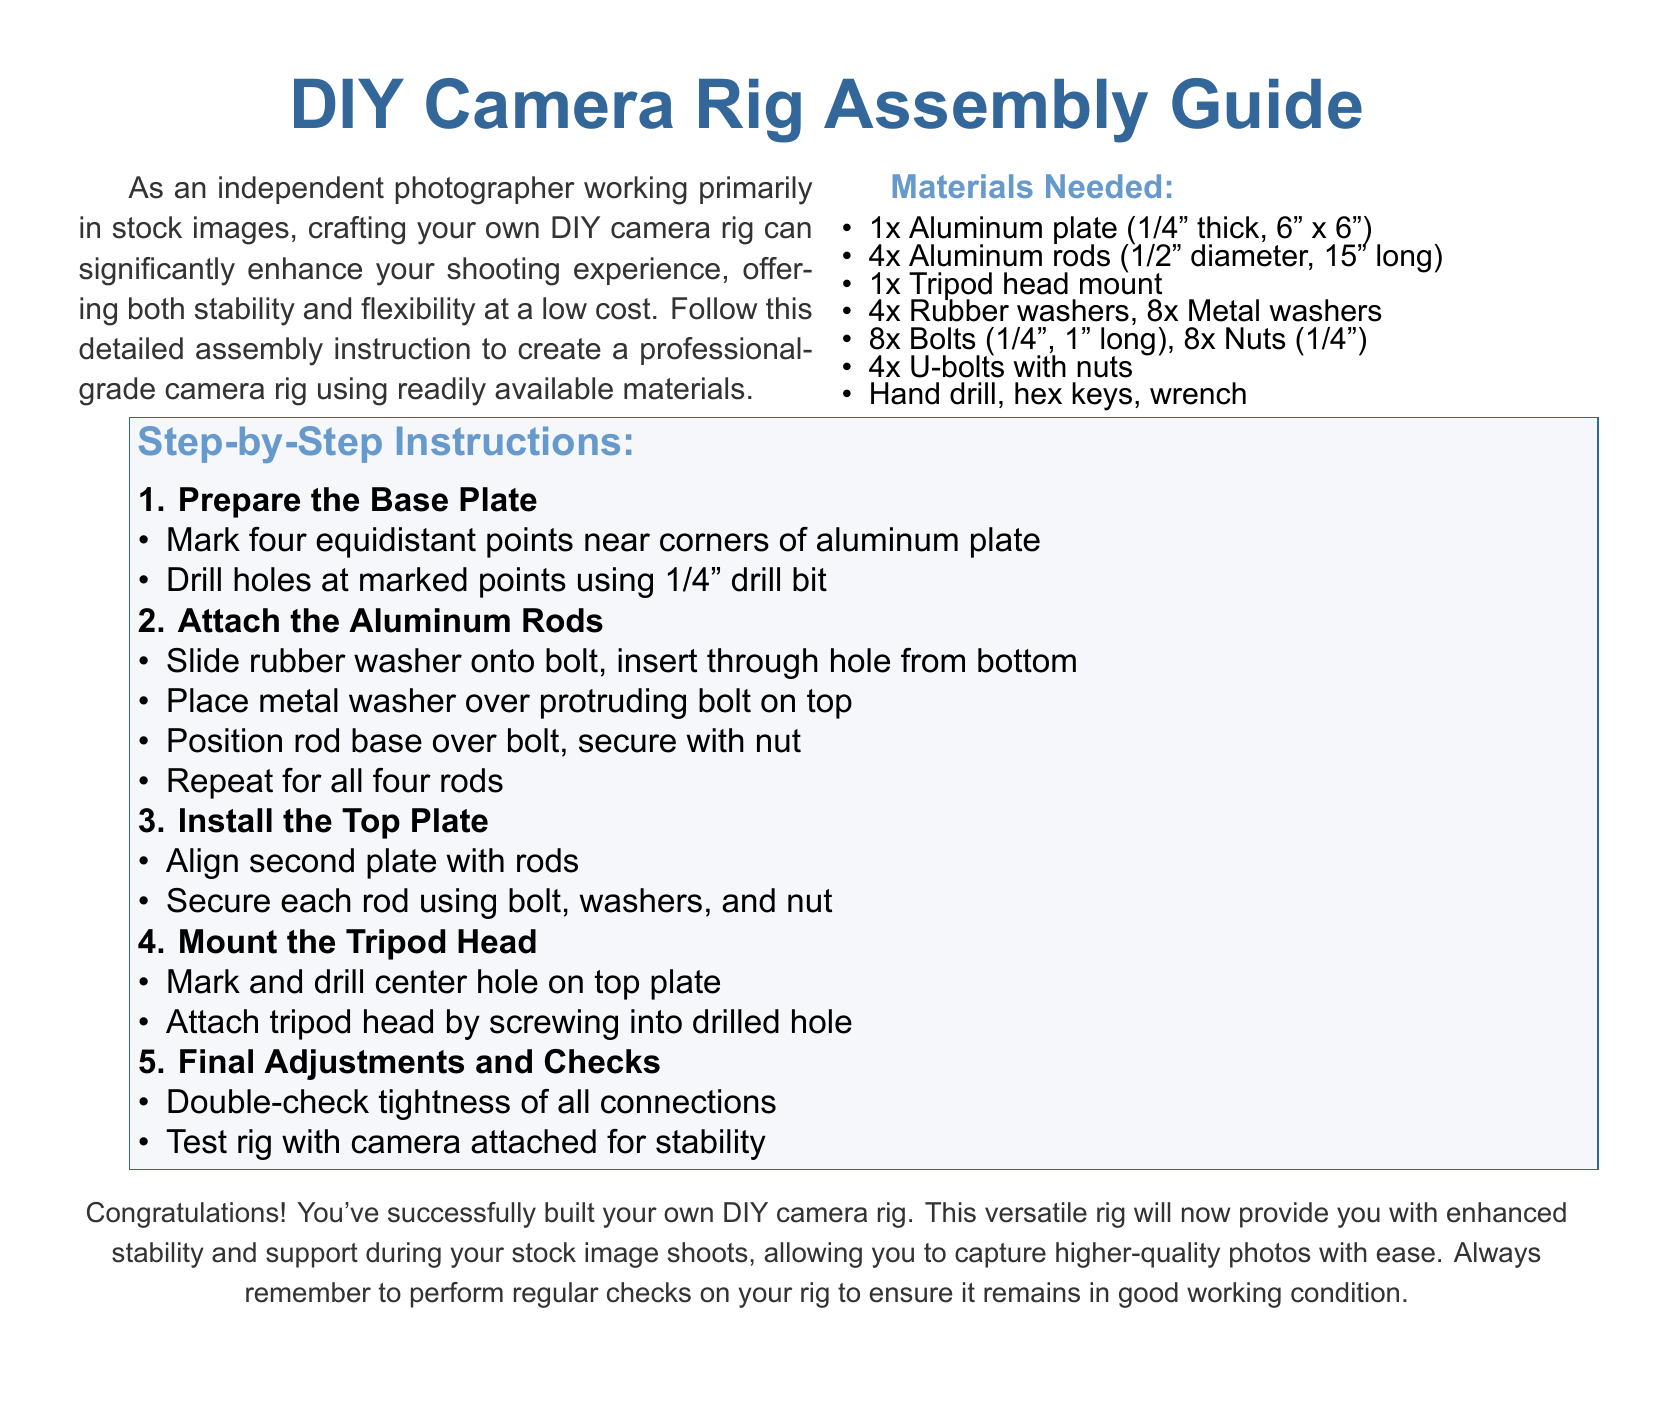What is the thickness of the aluminum plate? The thickness of the aluminum plate needed for the rig is specified in the materials list as 1/4".
Answer: 1/4" How many aluminum rods are required? The materials list indicates that you need 4 aluminum rods for the assembly.
Answer: 4 What tools are needed to build the camera rig? The document mentions that a hand drill, hex keys, and a wrench are required tools for assembly.
Answer: Hand drill, hex keys, wrench How many steps are there in the assembly instructions? The instructions are divided into five outlined steps.
Answer: 5 What is the purpose of rubber washers in the assembly process? Rubber washers are used for cushioning and securing the bolts when attaching the aluminum rods to the base plate.
Answer: Cushioning and securing In which step is the tripod head mounted? The tripod head is mounted in step 4 of the assembly instructions.
Answer: Step 4 What is the size of each aluminum rod? The document specifies that each aluminum rod has a diameter of 1/2" and a length of 15".
Answer: 1/2" diameter, 15" long What should be done after completing the assembly? After completing the assembly, the document advises to perform double-checks and test the rig with a camera attached for stability.
Answer: Double-check and test for stability What type of rig is being constructed? The guide refers to the rig being constructed as a DIY camera rig.
Answer: DIY camera rig 